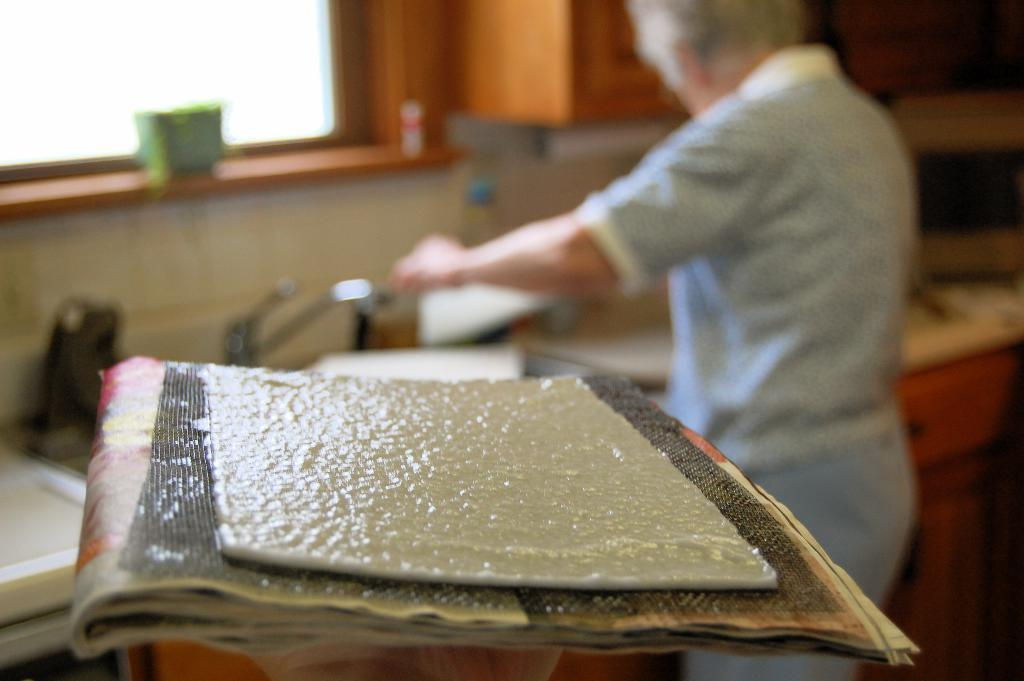What is the main object in the image? There is a cardboard on papers in the image. Can you describe the person in the image? There is a person in the image, and they are wearing clothes. How is the background of the person depicted? The background of the person is blurred. What reason does the beggar give for not having a mind in the image? There is no beggar present in the image, and therefore no reason can be given for not having a mind. 